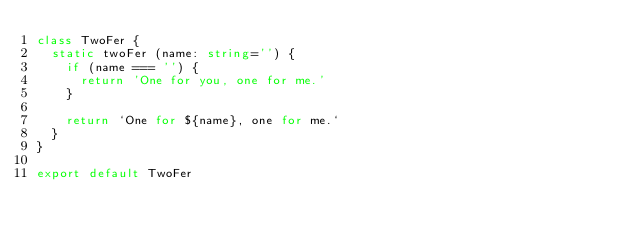<code> <loc_0><loc_0><loc_500><loc_500><_TypeScript_>class TwoFer {
  static twoFer (name: string='') {
    if (name === '') {
      return 'One for you, one for me.'
    }

    return `One for ${name}, one for me.`
  }
}

export default TwoFer
</code> 